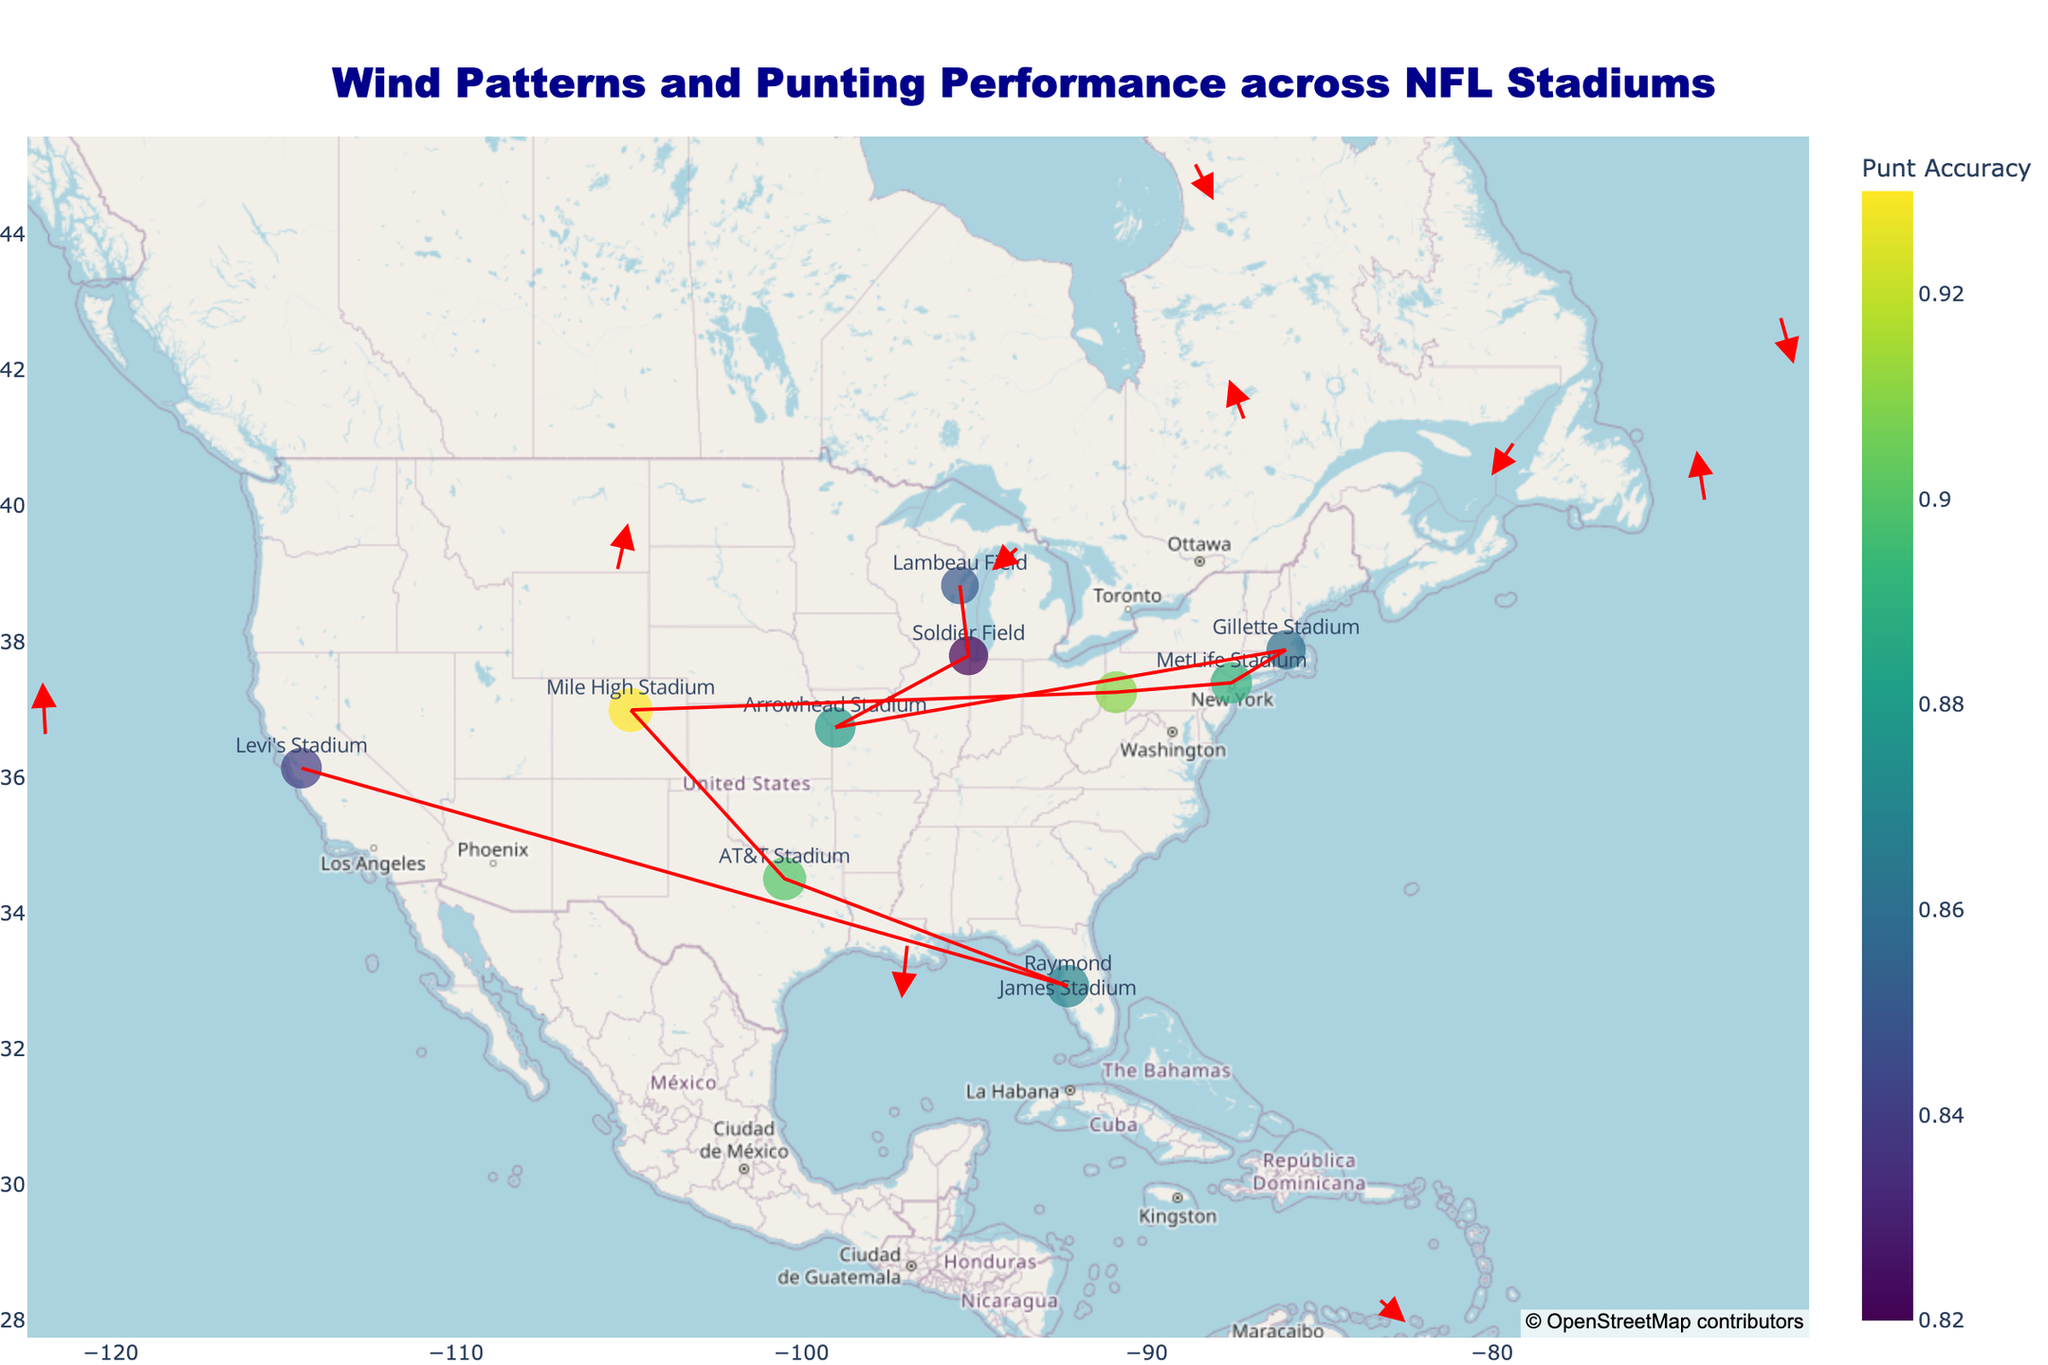how many stadiums are displayed in the figure? To determine the number of stadiums displayed, count the distinct markers or data points shown on the map. Each represents a different stadium.
Answer: 10 which stadium has the highest punt accuracy? Look for the data point or marker with the highest color scale value since the colors represent punt accuracy. Heinz Field, with an accuracy of 0.91, is the highest from the given data.
Answer: Heinz Field what is the average wind speed for Lembeau Field? Check the hover text or data point associated with Lambeau Field. Read the average wind speed value displayed.
Answer: 12.5 mph how many stadiums have an average punt distance greater than 50 yards? Identify the markers or text where the average punt distance exceeds 50 yards. This involves locating and counting the specific data points.
Answer: 3 which stadium has the strongest wind blowing northeast (positive x and y directions)? Examine the arrows indicating wind direction in the figure. Identify the stadium where the arrow points in the northeast direction and has the longest vector. AT&T Stadium has wind direction components (0.2, 1.0), indicating northeast.
Answer: AT&T Stadium what is the range of punt distances between the stadium with the longest average distance and the one with the shortest? Subtract the shortest average punt distance value (45.2 yards at Lambeau Field) from the longest (52.7 yards at Mile High Stadium).
Answer: 7.5 yards which stadium has the weakest wind speed and how does this compare to the stadium with the strongest wind speed? Identify the stadium with the smallest wind speed value (AT&T Stadium at 5.8 mph) and compare it to the stadium with the highest wind speed value (Lambeau Field at 12.5 mph).
Answer: AT&T Stadium is 6.7 mph weaker than Lambeau Field how is the stadium location data presented in the figure? Look for how longitude and latitude are represented as positions for each marker. The figure uses a scatter mapbox plot to show the geographical locations.
Answer: scatter mapbox plot what is the trend between average wind speed and punt accuracy based on the stadiums shown? Observe the colors of the markers along with the average wind speed values. Generally, lower wind speeds might correlate with higher punt accuracy, evidenced by Heinz Field and Mile High Stadium.
Answer: lower wind speeds correlate with higher punt accuracy 